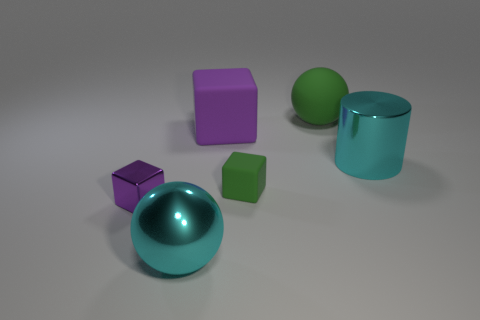Do the large metal cylinder and the metallic sphere have the same color?
Make the answer very short. Yes. There is a purple thing on the right side of the purple shiny cube; does it have the same size as the shiny block?
Your response must be concise. No. Are there any purple cubes of the same size as the cyan shiny cylinder?
Provide a succinct answer. Yes. The tiny cube to the right of the large purple matte object is what color?
Your answer should be very brief. Green. What is the shape of the metal object that is both behind the large cyan metal ball and on the left side of the cylinder?
Provide a succinct answer. Cube. How many shiny objects have the same shape as the big purple matte object?
Offer a very short reply. 1. How many small objects are there?
Your answer should be compact. 2. How big is the thing that is right of the small green block and behind the cylinder?
Keep it short and to the point. Large. What is the shape of the purple shiny thing that is the same size as the green matte cube?
Offer a terse response. Cube. There is a tiny thing that is behind the tiny shiny object; are there any large matte spheres in front of it?
Provide a succinct answer. No. 